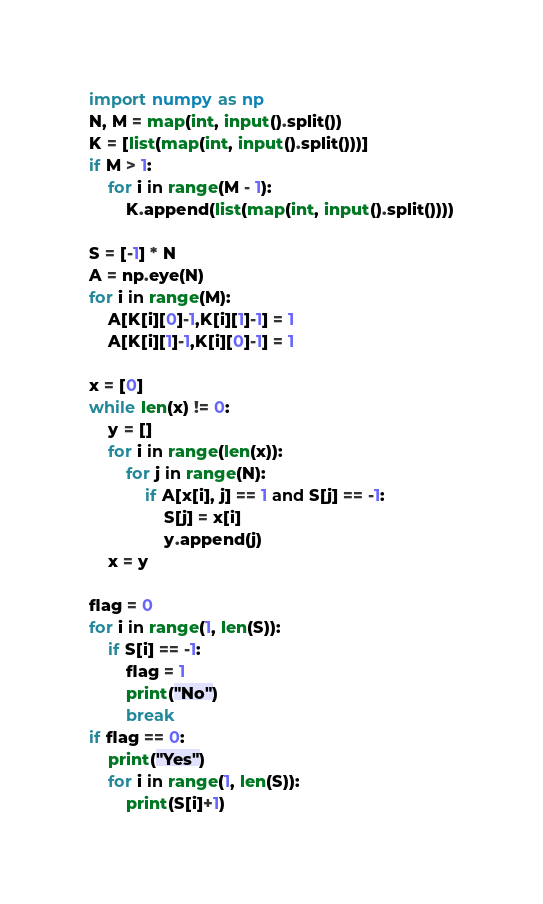Convert code to text. <code><loc_0><loc_0><loc_500><loc_500><_Python_>import numpy as np
N, M = map(int, input().split())
K = [list(map(int, input().split()))]
if M > 1:
    for i in range(M - 1):
        K.append(list(map(int, input().split())))

S = [-1] * N
A = np.eye(N)
for i in range(M):
    A[K[i][0]-1,K[i][1]-1] = 1
    A[K[i][1]-1,K[i][0]-1] = 1

x = [0]
while len(x) != 0:
    y = []
    for i in range(len(x)):
        for j in range(N):
            if A[x[i], j] == 1 and S[j] == -1:
                S[j] = x[i]
                y.append(j)
    x = y

flag = 0
for i in range(1, len(S)):
    if S[i] == -1:
        flag = 1
        print("No")
        break
if flag == 0:
    print("Yes")
    for i in range(1, len(S)):
        print(S[i]+1)
</code> 